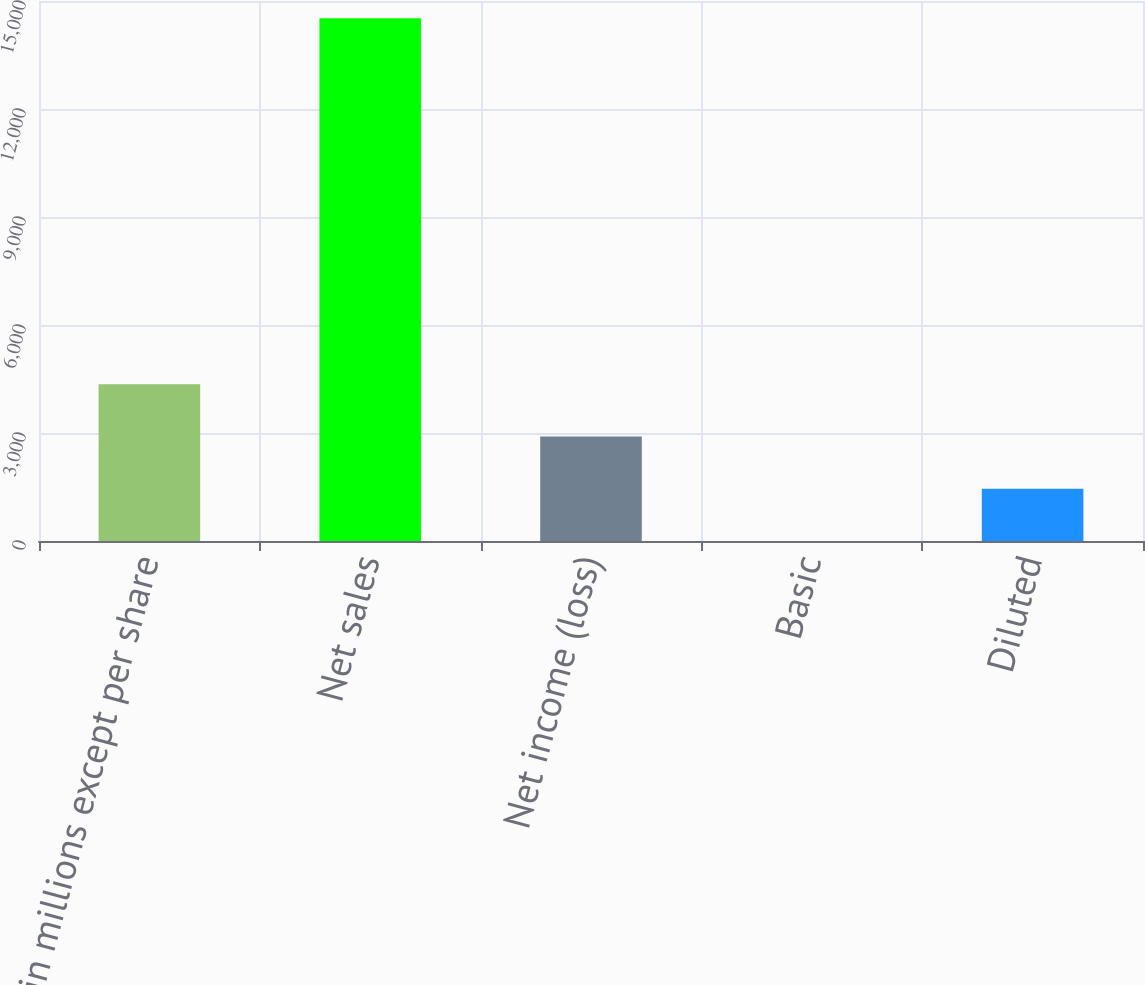<chart> <loc_0><loc_0><loc_500><loc_500><bar_chart><fcel>(in millions except per share<fcel>Net sales<fcel>Net income (loss)<fcel>Basic<fcel>Diluted<nl><fcel>4356.26<fcel>14519.6<fcel>2904.35<fcel>0.53<fcel>1452.44<nl></chart> 